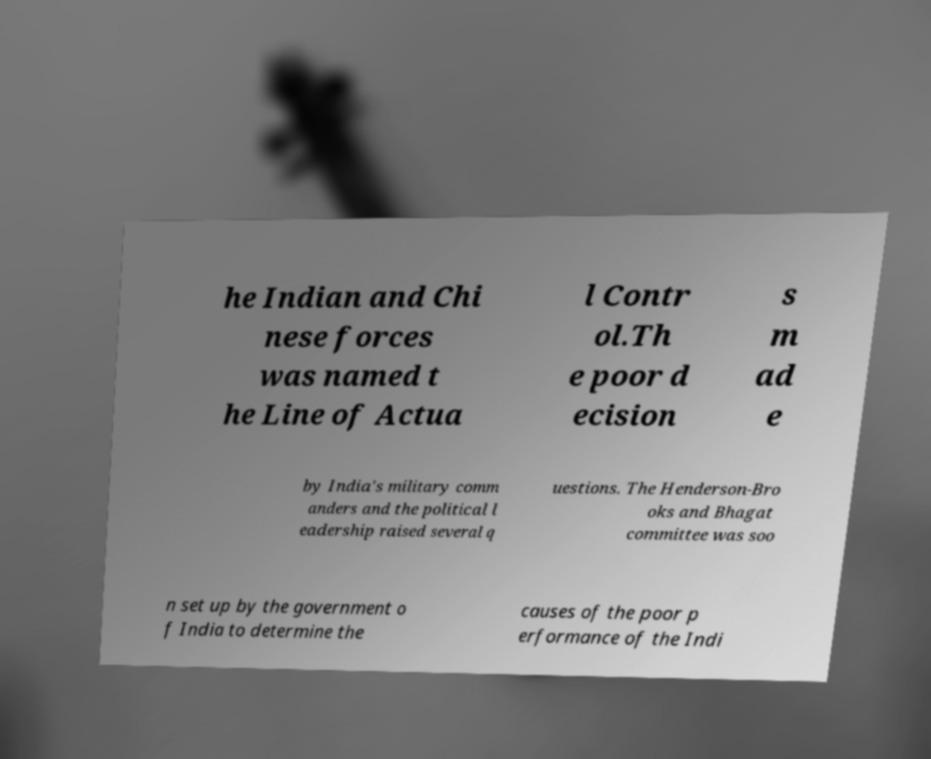For documentation purposes, I need the text within this image transcribed. Could you provide that? he Indian and Chi nese forces was named t he Line of Actua l Contr ol.Th e poor d ecision s m ad e by India's military comm anders and the political l eadership raised several q uestions. The Henderson-Bro oks and Bhagat committee was soo n set up by the government o f India to determine the causes of the poor p erformance of the Indi 